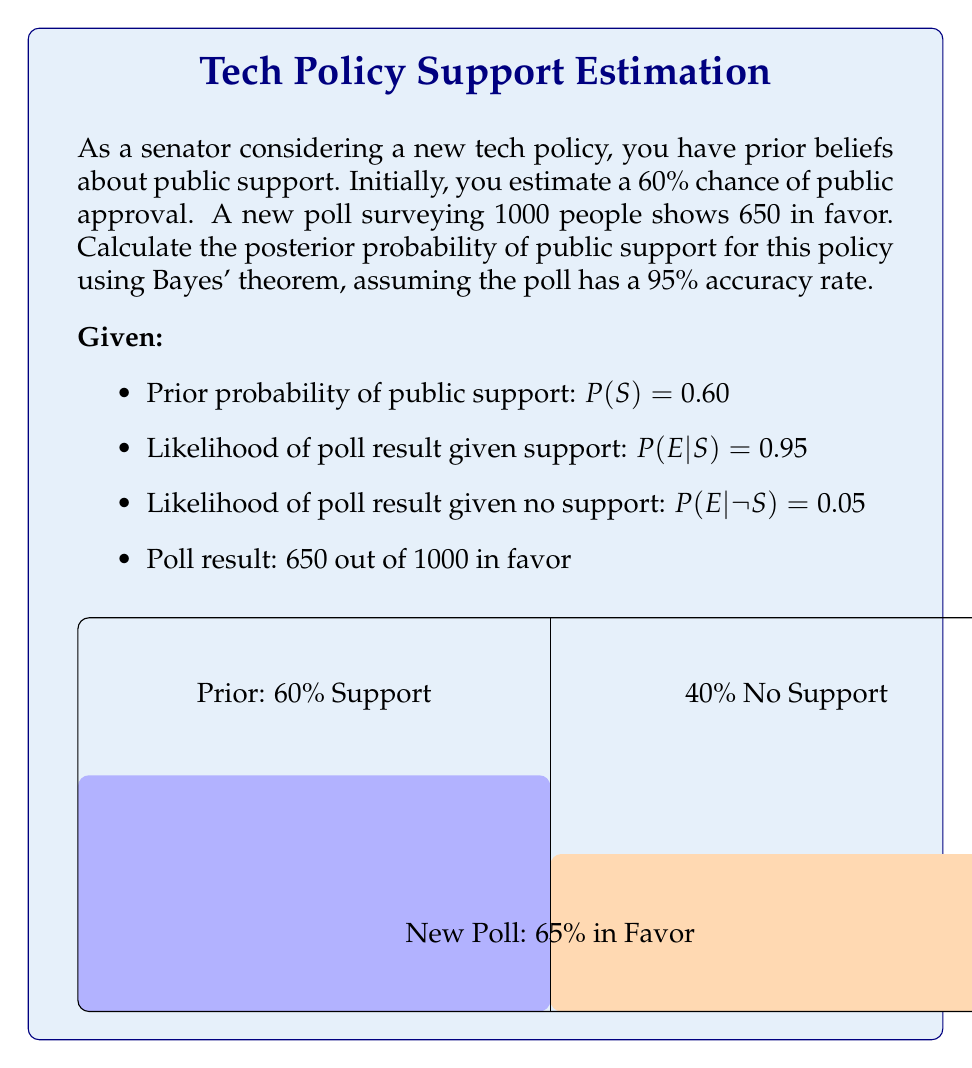Can you solve this math problem? Let's solve this step-by-step using Bayes' theorem:

1) Bayes' theorem states:
   $$P(S|E) = \frac{P(E|S) \cdot P(S)}{P(E)}$$

   Where:
   $P(S|E)$ is the posterior probability of support given the evidence
   $P(E|S)$ is the likelihood of the evidence given support
   $P(S)$ is the prior probability of support
   $P(E)$ is the total probability of the evidence

2) We're given $P(S) = 0.60$, $P(E|S) = 0.95$, and $P(E|\neg S) = 0.05$

3) To find $P(E)$, we use the law of total probability:
   $$P(E) = P(E|S) \cdot P(S) + P(E|\neg S) \cdot P(\neg S)$$
   $$P(E) = 0.95 \cdot 0.60 + 0.05 \cdot 0.40 = 0.57 + 0.02 = 0.59$$

4) Now we can apply Bayes' theorem:
   $$P(S|E) = \frac{0.95 \cdot 0.60}{0.59} \approx 0.9661$$

5) Convert to percentage: 0.9661 * 100 ≈ 96.61%

Thus, after considering the new poll data, the posterior probability of public support for the policy is approximately 96.61%.
Answer: 96.61% 